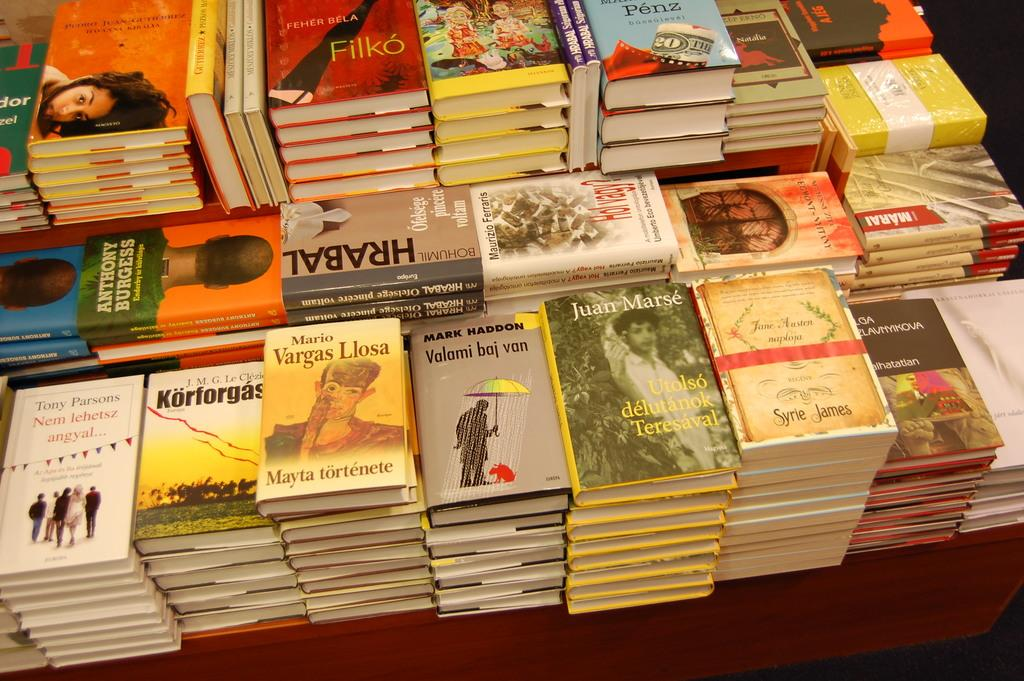<image>
Present a compact description of the photo's key features. A table filled with stacks of books, one by Vargas Llosa 